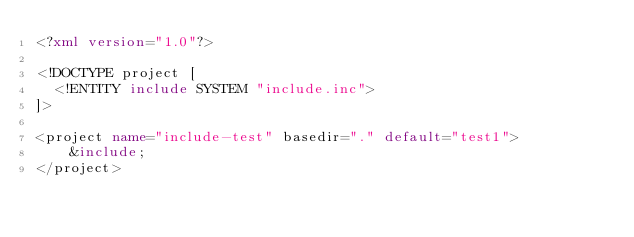Convert code to text. <code><loc_0><loc_0><loc_500><loc_500><_XML_><?xml version="1.0"?>

<!DOCTYPE project [
  <!ENTITY include SYSTEM "include.inc">
]>

<project name="include-test" basedir="." default="test1">
    &include;
</project>
</code> 